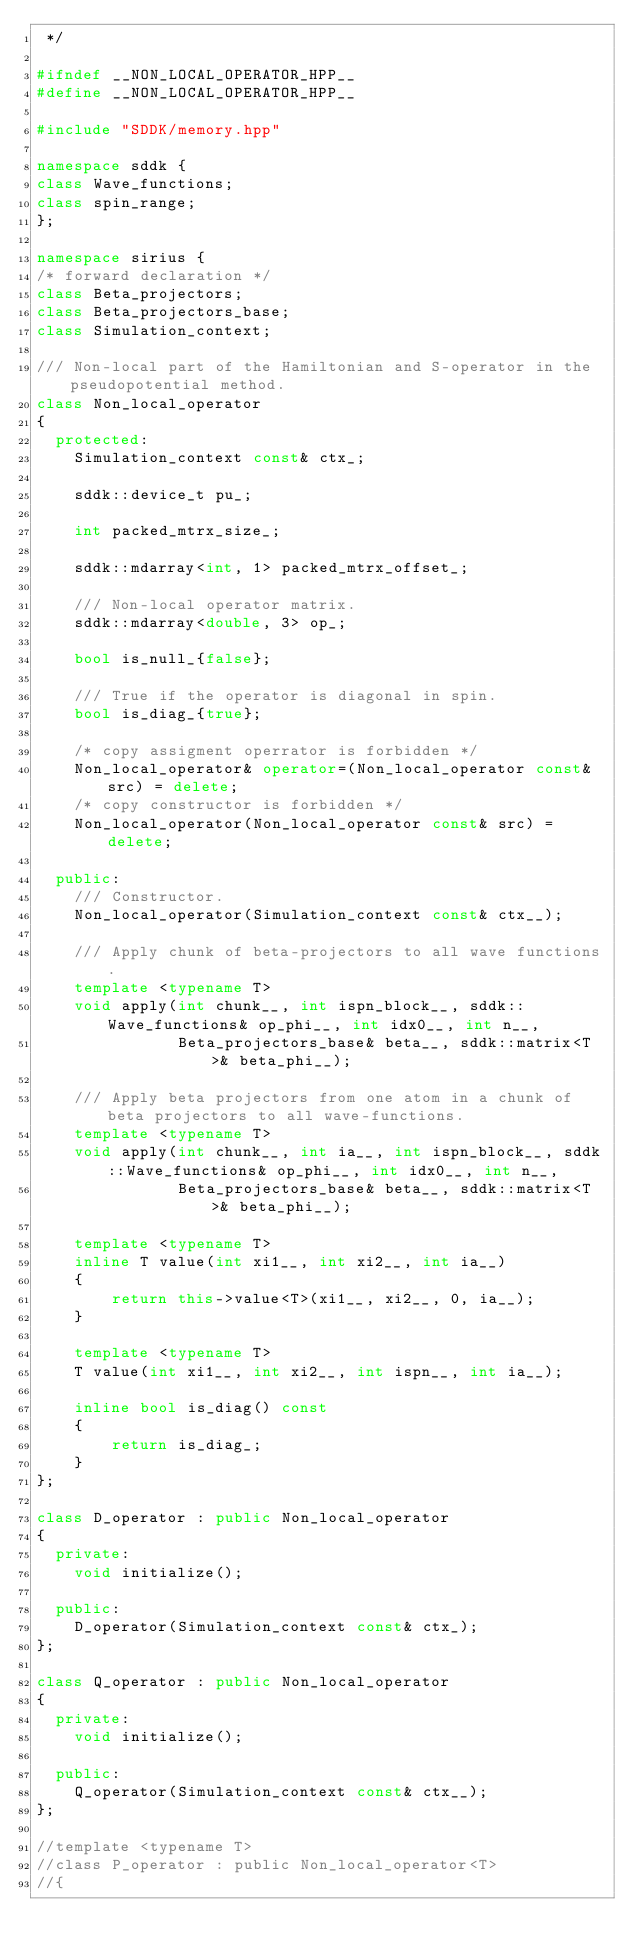<code> <loc_0><loc_0><loc_500><loc_500><_C++_> */

#ifndef __NON_LOCAL_OPERATOR_HPP__
#define __NON_LOCAL_OPERATOR_HPP__

#include "SDDK/memory.hpp"

namespace sddk {
class Wave_functions;
class spin_range;
};

namespace sirius {
/* forward declaration */
class Beta_projectors;
class Beta_projectors_base;
class Simulation_context;

/// Non-local part of the Hamiltonian and S-operator in the pseudopotential method.
class Non_local_operator
{
  protected:
    Simulation_context const& ctx_;

    sddk::device_t pu_;

    int packed_mtrx_size_;

    sddk::mdarray<int, 1> packed_mtrx_offset_;

    /// Non-local operator matrix.
    sddk::mdarray<double, 3> op_;

    bool is_null_{false};

    /// True if the operator is diagonal in spin.
    bool is_diag_{true};

    /* copy assigment operrator is forbidden */
    Non_local_operator& operator=(Non_local_operator const& src) = delete;
    /* copy constructor is forbidden */
    Non_local_operator(Non_local_operator const& src) = delete;

  public:
    /// Constructor.
    Non_local_operator(Simulation_context const& ctx__);

    /// Apply chunk of beta-projectors to all wave functions.
    template <typename T>
    void apply(int chunk__, int ispn_block__, sddk::Wave_functions& op_phi__, int idx0__, int n__,
               Beta_projectors_base& beta__, sddk::matrix<T>& beta_phi__);

    /// Apply beta projectors from one atom in a chunk of beta projectors to all wave-functions.
    template <typename T>
    void apply(int chunk__, int ia__, int ispn_block__, sddk::Wave_functions& op_phi__, int idx0__, int n__,
               Beta_projectors_base& beta__, sddk::matrix<T>& beta_phi__);

    template <typename T>
    inline T value(int xi1__, int xi2__, int ia__)
    {
        return this->value<T>(xi1__, xi2__, 0, ia__);
    }

    template <typename T>
    T value(int xi1__, int xi2__, int ispn__, int ia__);

    inline bool is_diag() const
    {
        return is_diag_;
    }
};

class D_operator : public Non_local_operator
{
  private:
    void initialize();

  public:
    D_operator(Simulation_context const& ctx_);
};

class Q_operator : public Non_local_operator
{
  private:
    void initialize();

  public:
    Q_operator(Simulation_context const& ctx__);
};

//template <typename T>
//class P_operator : public Non_local_operator<T>
//{</code> 